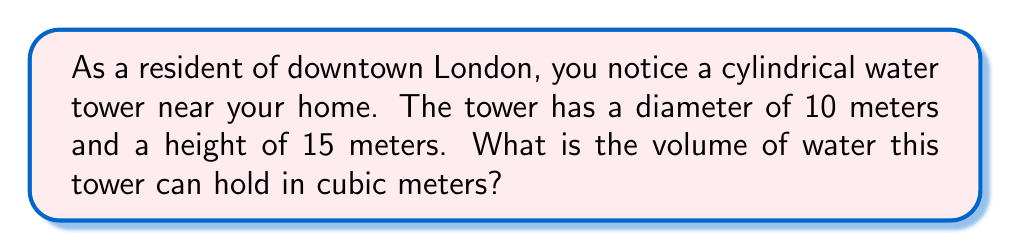Show me your answer to this math problem. To find the volume of a cylindrical water tower, we need to use the formula for the volume of a cylinder:

$$V = \pi r^2 h$$

Where:
$V$ = volume
$r$ = radius of the base
$h$ = height of the cylinder

Given:
- Diameter = 10 meters
- Height = 15 meters

Step 1: Calculate the radius
The radius is half the diameter:
$r = 10 \div 2 = 5$ meters

Step 2: Apply the volume formula
$$\begin{align}
V &= \pi r^2 h \\
&= \pi \cdot (5\text{ m})^2 \cdot 15\text{ m} \\
&= \pi \cdot 25\text{ m}^2 \cdot 15\text{ m} \\
&= 375\pi\text{ m}^3
\end{align}$$

Step 3: Calculate the final value
$375\pi \approx 1,178.10$ cubic meters

Therefore, the water tower can hold approximately 1,178.10 cubic meters of water.
Answer: $375\pi$ m³ or approximately 1,178.10 m³ 